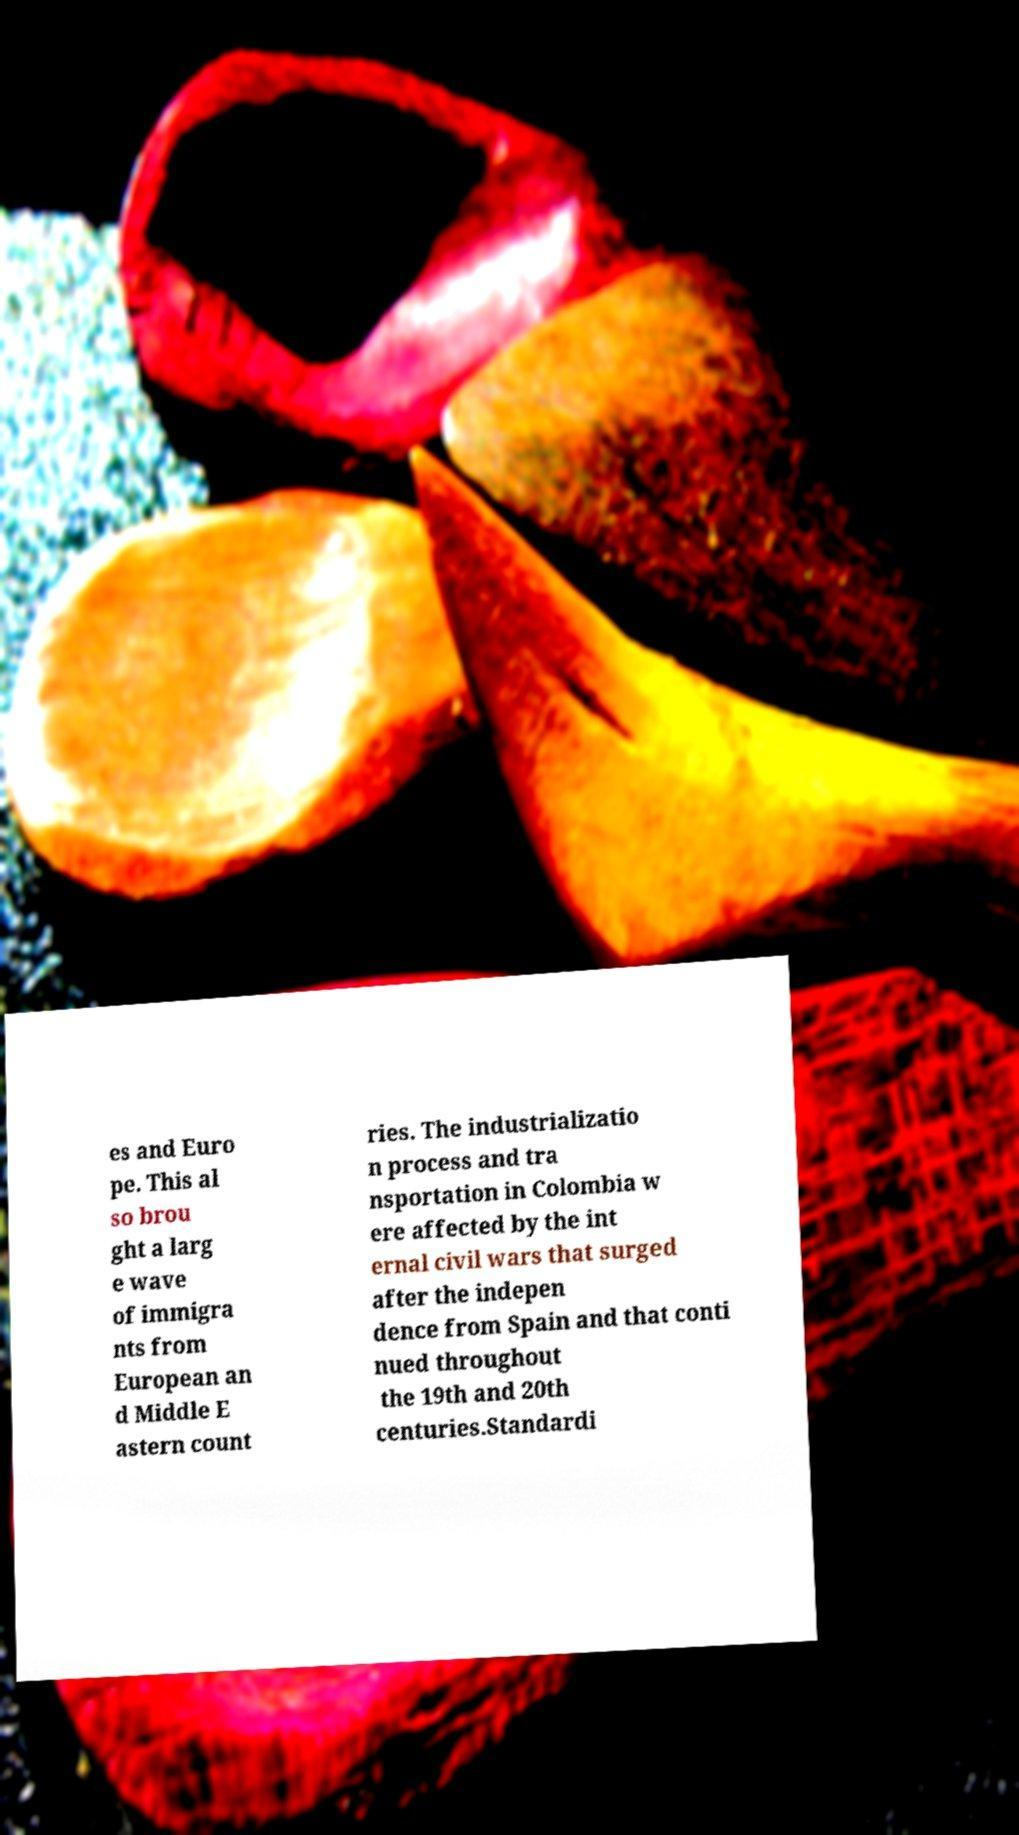I need the written content from this picture converted into text. Can you do that? es and Euro pe. This al so brou ght a larg e wave of immigra nts from European an d Middle E astern count ries. The industrializatio n process and tra nsportation in Colombia w ere affected by the int ernal civil wars that surged after the indepen dence from Spain and that conti nued throughout the 19th and 20th centuries.Standardi 